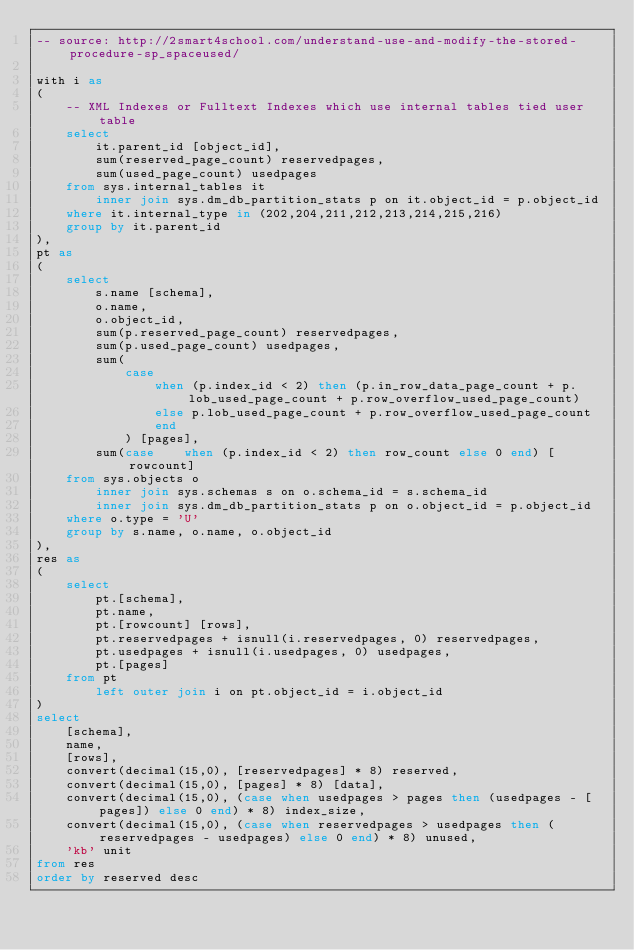Convert code to text. <code><loc_0><loc_0><loc_500><loc_500><_SQL_>-- source: http://2smart4school.com/understand-use-and-modify-the-stored-procedure-sp_spaceused/

with i as
(
	-- XML Indexes or Fulltext Indexes which use internal tables tied user table
	select
		it.parent_id [object_id],
		sum(reserved_page_count) reservedpages,
		sum(used_page_count) usedpages
	from sys.internal_tables it
		inner join sys.dm_db_partition_stats p on it.object_id = p.object_id
	where it.internal_type in (202,204,211,212,213,214,215,216)
	group by it.parent_id
),
pt as
(
	select
		s.name [schema],
		o.name,
		o.object_id,
		sum(p.reserved_page_count) reservedpages,
		sum(p.used_page_count) usedpages,
		sum(
			case
				when (p.index_id < 2) then (p.in_row_data_page_count + p.lob_used_page_count + p.row_overflow_used_page_count)
				else p.lob_used_page_count + p.row_overflow_used_page_count
				end
			) [pages],
		sum(case	when (p.index_id < 2) then row_count else 0 end) [rowcount]
	from sys.objects o
		inner join sys.schemas s on o.schema_id = s.schema_id
		inner join sys.dm_db_partition_stats p on o.object_id = p.object_id
	where o.type = 'U'
	group by s.name, o.name, o.object_id
),
res as
(
	select
		pt.[schema],
		pt.name,
		pt.[rowcount] [rows],
		pt.reservedpages + isnull(i.reservedpages, 0) reservedpages,
		pt.usedpages + isnull(i.usedpages, 0) usedpages,
		pt.[pages]
	from pt
		left outer join i on pt.object_id = i.object_id
)
select
	[schema],
	name,
	[rows],
	convert(decimal(15,0), [reservedpages] * 8) reserved,
	convert(decimal(15,0), [pages] * 8) [data],
	convert(decimal(15,0), (case when usedpages > pages then (usedpages - [pages]) else 0 end) * 8) index_size,
	convert(decimal(15,0), (case when reservedpages > usedpages then (reservedpages - usedpages) else 0 end) * 8) unused,
	'kb' unit
from res
order by reserved desc
</code> 